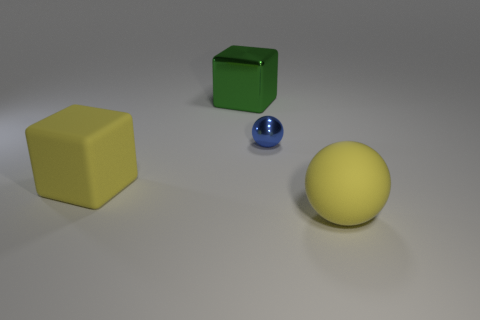Add 3 tiny green metallic objects. How many objects exist? 7 Subtract 0 red cylinders. How many objects are left? 4 Subtract all big yellow matte objects. Subtract all red rubber cubes. How many objects are left? 2 Add 1 green cubes. How many green cubes are left? 2 Add 4 big yellow objects. How many big yellow objects exist? 6 